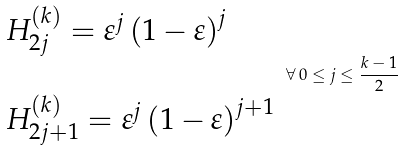<formula> <loc_0><loc_0><loc_500><loc_500>\begin{array} { l } H _ { 2 j } ^ { \left ( k \right ) } = \varepsilon ^ { j } \left ( 1 - \varepsilon \right ) ^ { j } \\ \\ H _ { 2 j + 1 } ^ { \left ( k \right ) } = \varepsilon ^ { j } \left ( 1 - \varepsilon \right ) ^ { j + 1 } \end{array} \, \forall \, 0 \leq j \leq \frac { k - 1 } 2</formula> 